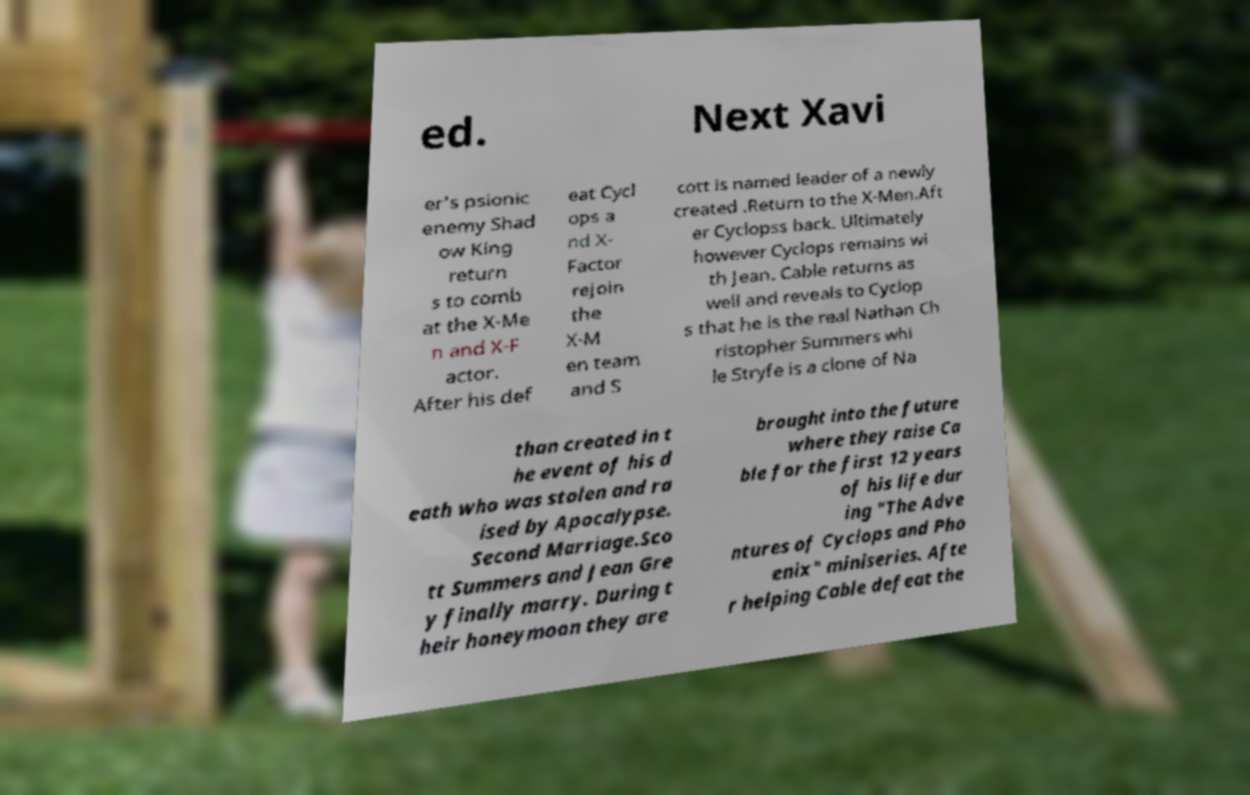There's text embedded in this image that I need extracted. Can you transcribe it verbatim? ed. Next Xavi er's psionic enemy Shad ow King return s to comb at the X-Me n and X-F actor. After his def eat Cycl ops a nd X- Factor rejoin the X-M en team and S cott is named leader of a newly created .Return to the X-Men.Aft er Cyclopss back. Ultimately however Cyclops remains wi th Jean. Cable returns as well and reveals to Cyclop s that he is the real Nathan Ch ristopher Summers whi le Stryfe is a clone of Na than created in t he event of his d eath who was stolen and ra ised by Apocalypse. Second Marriage.Sco tt Summers and Jean Gre y finally marry. During t heir honeymoon they are brought into the future where they raise Ca ble for the first 12 years of his life dur ing "The Adve ntures of Cyclops and Pho enix" miniseries. Afte r helping Cable defeat the 